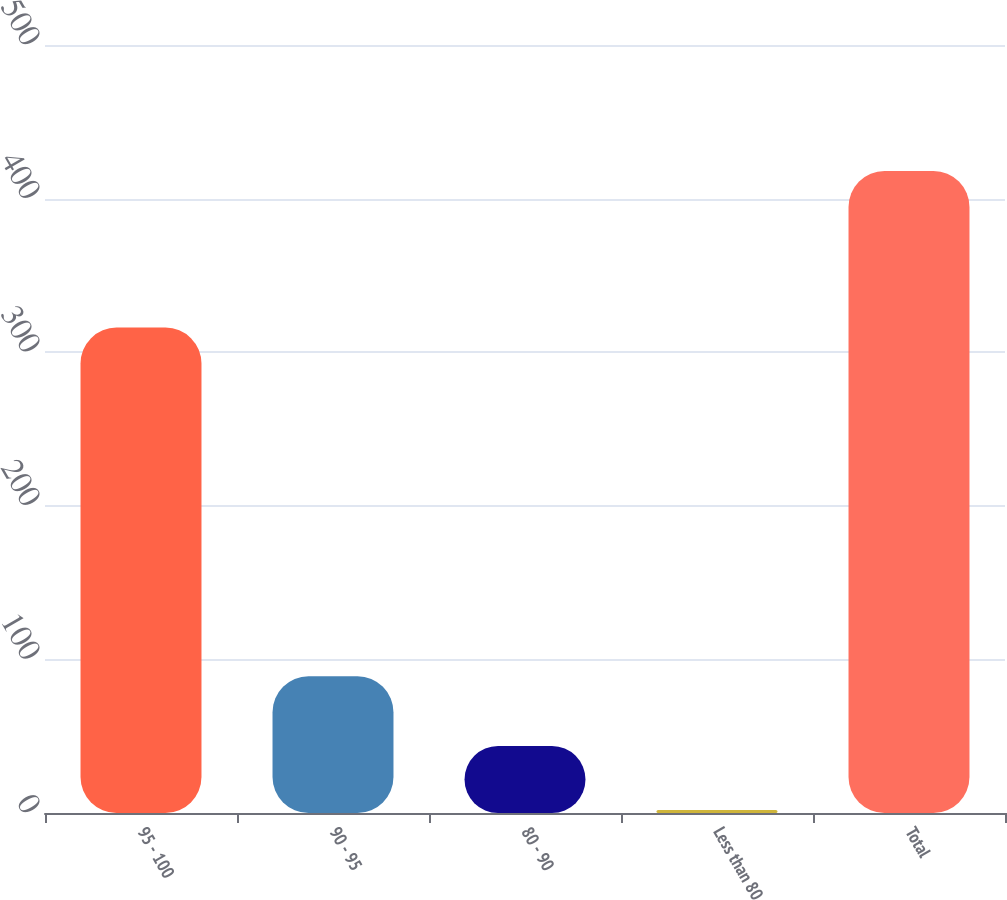<chart> <loc_0><loc_0><loc_500><loc_500><bar_chart><fcel>95 - 100<fcel>90 - 95<fcel>80 - 90<fcel>Less than 80<fcel>Total<nl><fcel>316<fcel>89<fcel>43.6<fcel>2<fcel>418<nl></chart> 